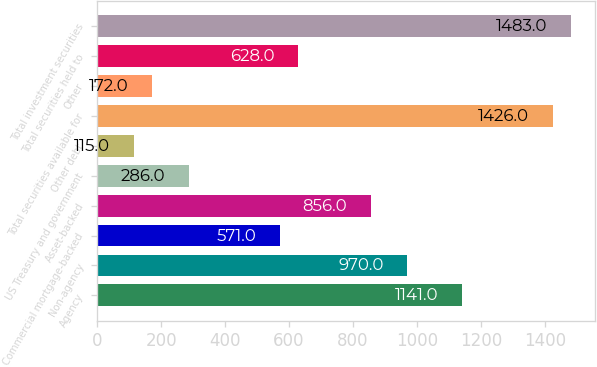<chart> <loc_0><loc_0><loc_500><loc_500><bar_chart><fcel>Agency<fcel>Non-agency<fcel>Commercial mortgage-backed<fcel>Asset-backed<fcel>US Treasury and government<fcel>Other debt<fcel>Total securities available for<fcel>Other<fcel>Total securities held to<fcel>Total investment securities<nl><fcel>1141<fcel>970<fcel>571<fcel>856<fcel>286<fcel>115<fcel>1426<fcel>172<fcel>628<fcel>1483<nl></chart> 